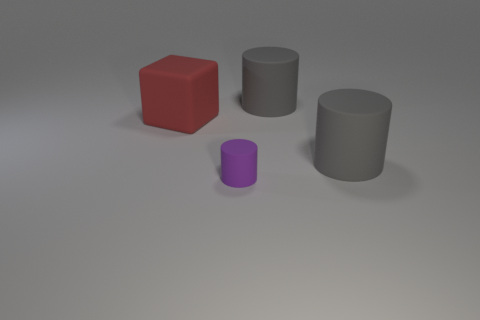Subtract all blue cylinders. Subtract all blue balls. How many cylinders are left? 3 Add 2 blue objects. How many objects exist? 6 Subtract all cylinders. How many objects are left? 1 Add 1 tiny rubber cylinders. How many tiny rubber cylinders exist? 2 Subtract 0 green cylinders. How many objects are left? 4 Subtract all red blocks. Subtract all large things. How many objects are left? 0 Add 4 big cylinders. How many big cylinders are left? 6 